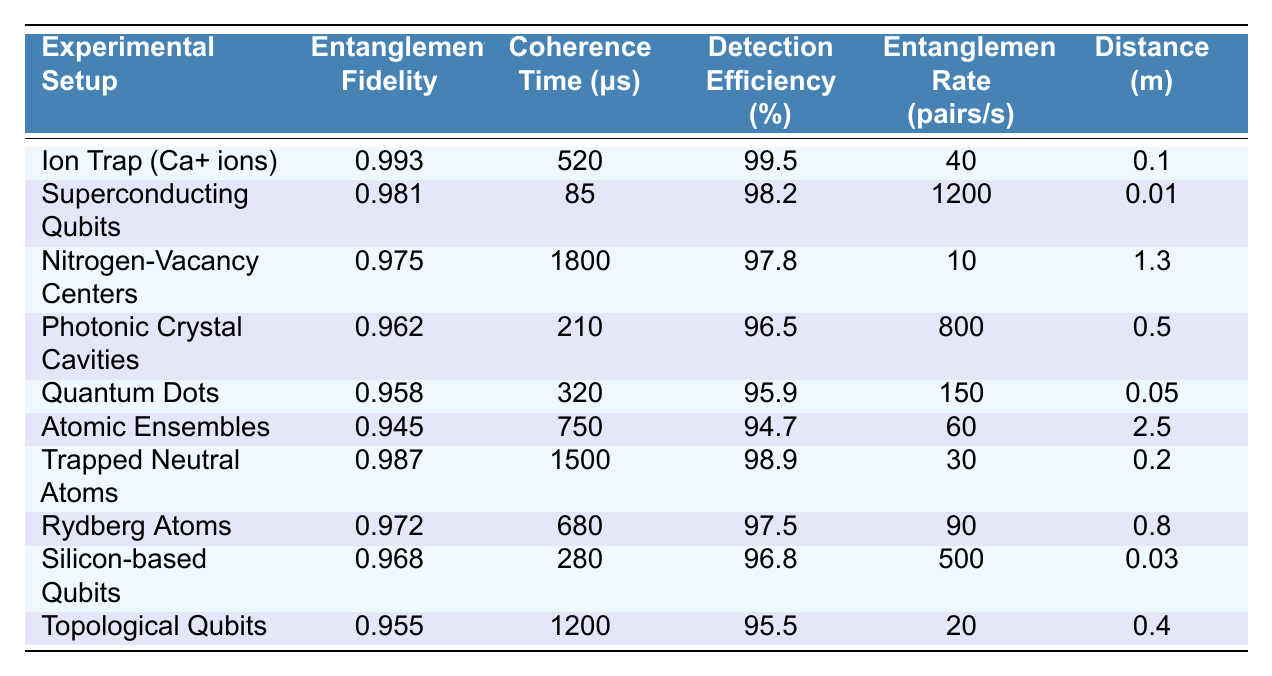What is the entanglement fidelity of Ion Trap (Ca+ ions)? From the table, I can see that the entanglement fidelity for Ion Trap (Ca+ ions) is listed directly under the corresponding experimental setup. The value is 0.993.
Answer: 0.993 Which experimental setup has the highest coherence time? I review the coherence time values for each experimental setup and find that Nitrogen-Vacancy Centers have the highest coherence time at 1800 μs.
Answer: Nitrogen-Vacancy Centers What is the average detection efficiency across all setups? To find the average detection efficiency, I sum all the detection efficiency values: (99.5 + 98.2 + 97.8 + 96.5 + 95.9 + 94.7 + 98.9 + 97.5 + 96.8 + 95.5) = 979.8. There are 10 setups, so the average is 979.8 / 10 = 97.98%.
Answer: 97.98% Is there an experimental setup with both a high entanglement fidelity (above 0.98) and high detection efficiency (above 98%)? I check the values for entanglement fidelity and detection efficiency across the table. Ion Trap (Ca+ ions) has an entanglement fidelity of 0.993 and a detection efficiency of 99.5%, which means it meets both criteria.
Answer: Yes What is the difference in entanglement rates between Superconducting Qubits and Quantum Dots? From the table, the entanglement rate for Superconducting Qubits is 1200 pairs/s and for Quantum Dots, it is 150 pairs/s. The difference is 1200 - 150 = 1050 pairs/s.
Answer: 1050 pairs/s Which experimental setup has the lowest entanglement rate and what is that rate? Reviewing the entanglement rates, I see that Atomic Ensembles has the lowest rate at 60 pairs/s.
Answer: Atomic Ensembles, 60 pairs/s If I sum all the coherence times, what result do I get? I take the coherence times from each setup: 520 + 85 + 1800 + 210 + 320 + 750 + 1500 + 680 + 280 + 1200 = 5,555 μs. This is the total coherence time across all setups.
Answer: 5555 μs How many setups have detection efficiencies over 98%? By examining the detection efficiency percentages, I find that six setups (Ion Trap, Superconducting Qubits, Trapped Neutral Atoms, Nitrogen-Vacancy Centers, Photonic Crystal Cavities, and Rydberg Atoms) have values above 98%.
Answer: 6 What is the relationship between coherence time and entanglement fidelity in this table? I analyze the table to see if there's a visible trend; indeed, higher coherence times do tend to correlate with higher entanglement fidelity in several cases, such as in Nitrogen-Vacancy Centers and Trapped Neutral Atoms. However, this is no strict rule, as seen in others like Quantum Dots.
Answer: Generally positive correlation, but not strict Which experimental setup can achieve entanglement over the largest distance? The distance values indicate that Atomic Ensembles can achieve entanglement over the longest distance of 2.5 meters, more than any other setup.
Answer: Atomic Ensembles, 2.5 m 